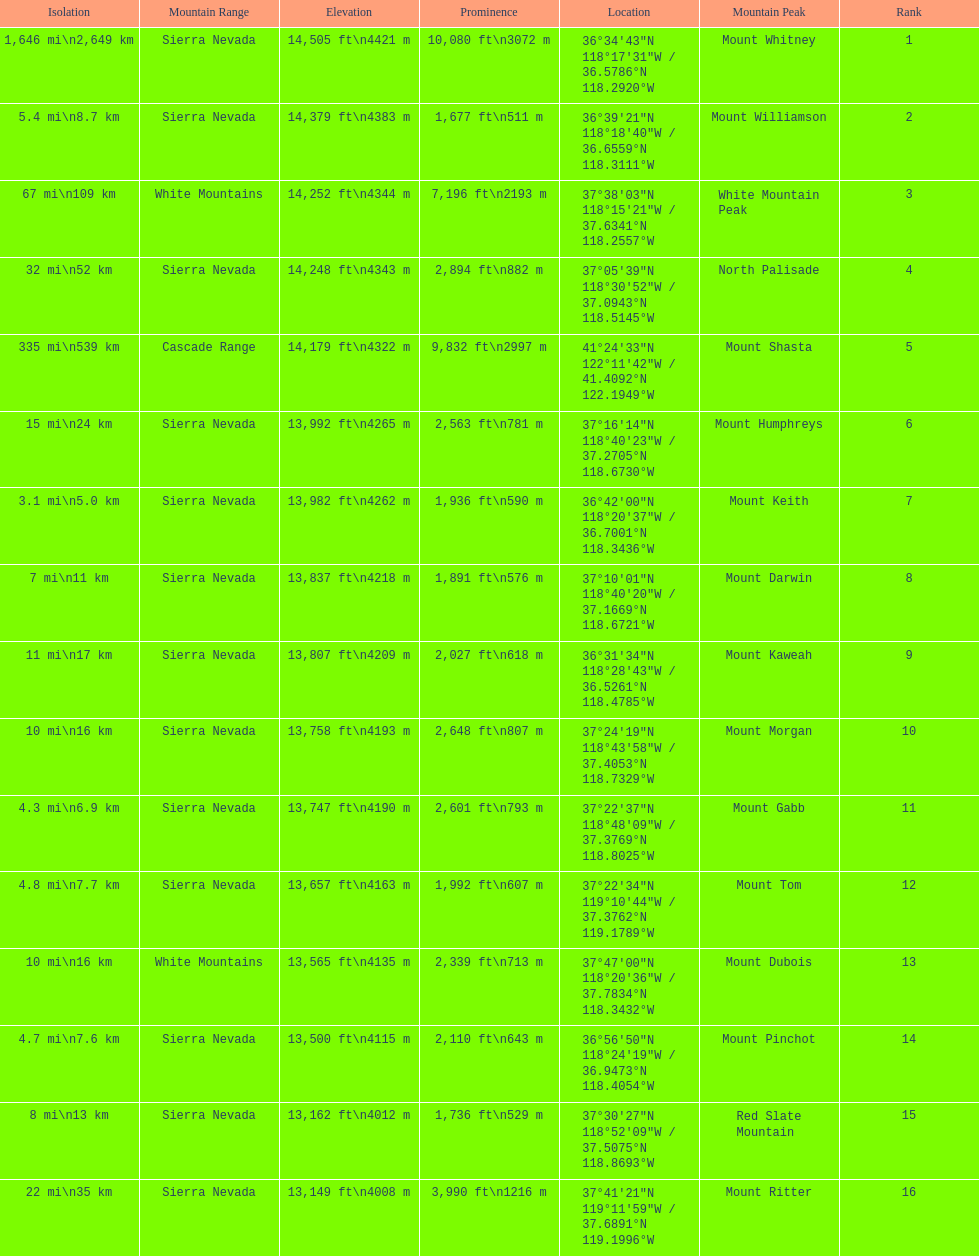Which mountain peak has a prominence more than 10,000 ft? Mount Whitney. 